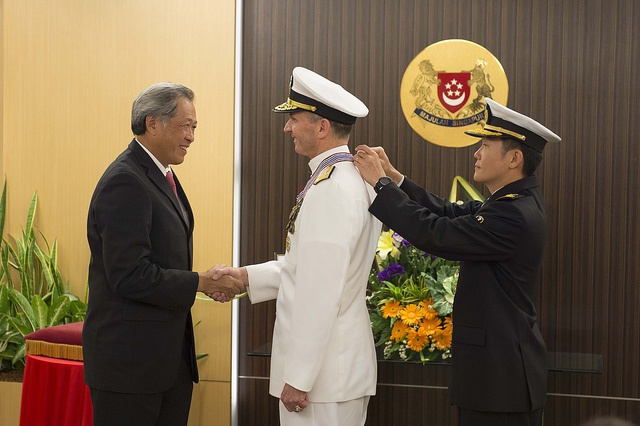Describe the objects in this image and their specific colors. I can see people in tan, black, gray, and maroon tones, people in tan, lightgray, and darkgray tones, people in tan, black, gray, and maroon tones, potted plant in tan, black, darkgreen, red, and orange tones, and potted plant in tan, darkgreen, olive, and black tones in this image. 